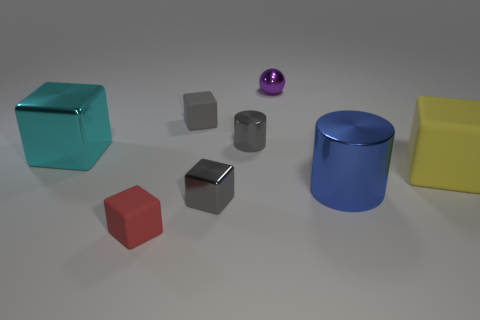Subtract all cylinders. How many objects are left? 6 Subtract 1 cylinders. How many cylinders are left? 1 Subtract all brown balls. Subtract all blue blocks. How many balls are left? 1 Subtract all cyan cylinders. How many brown balls are left? 0 Subtract all large yellow cubes. Subtract all blocks. How many objects are left? 2 Add 2 tiny spheres. How many tiny spheres are left? 3 Add 2 blue metal objects. How many blue metal objects exist? 3 Add 1 large blue cylinders. How many objects exist? 9 Subtract all blue cylinders. How many cylinders are left? 1 Subtract all large rubber blocks. How many blocks are left? 4 